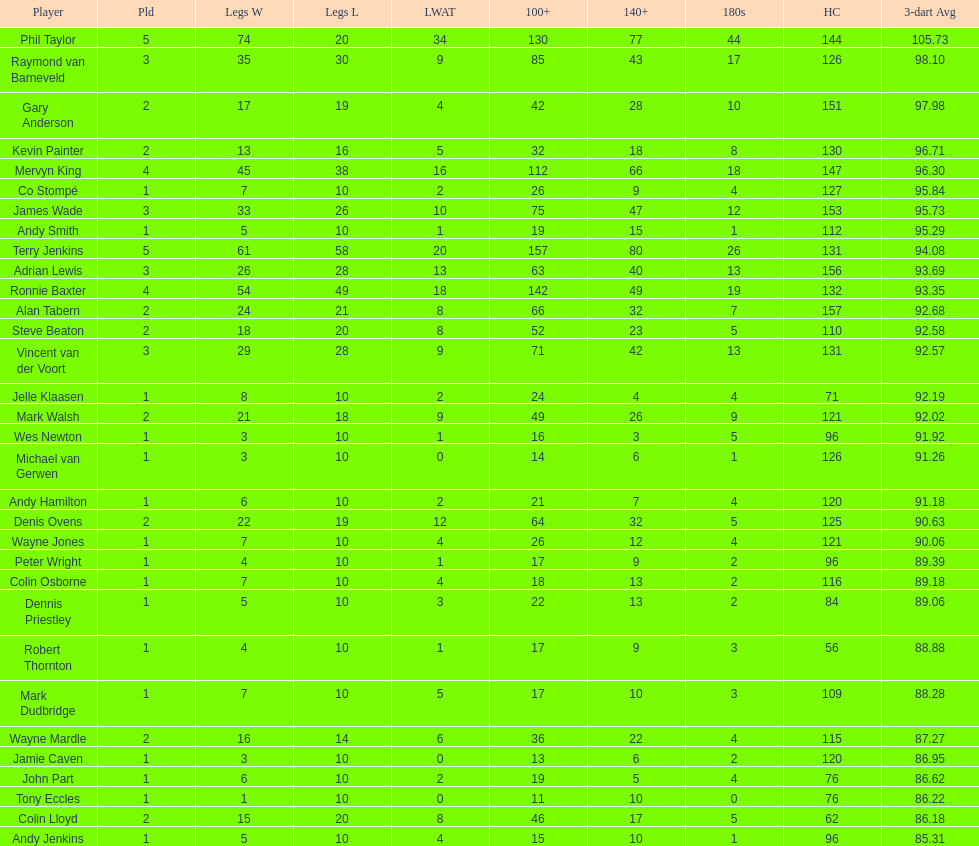71 for either andy smith or kevin painter? Kevin Painter. 